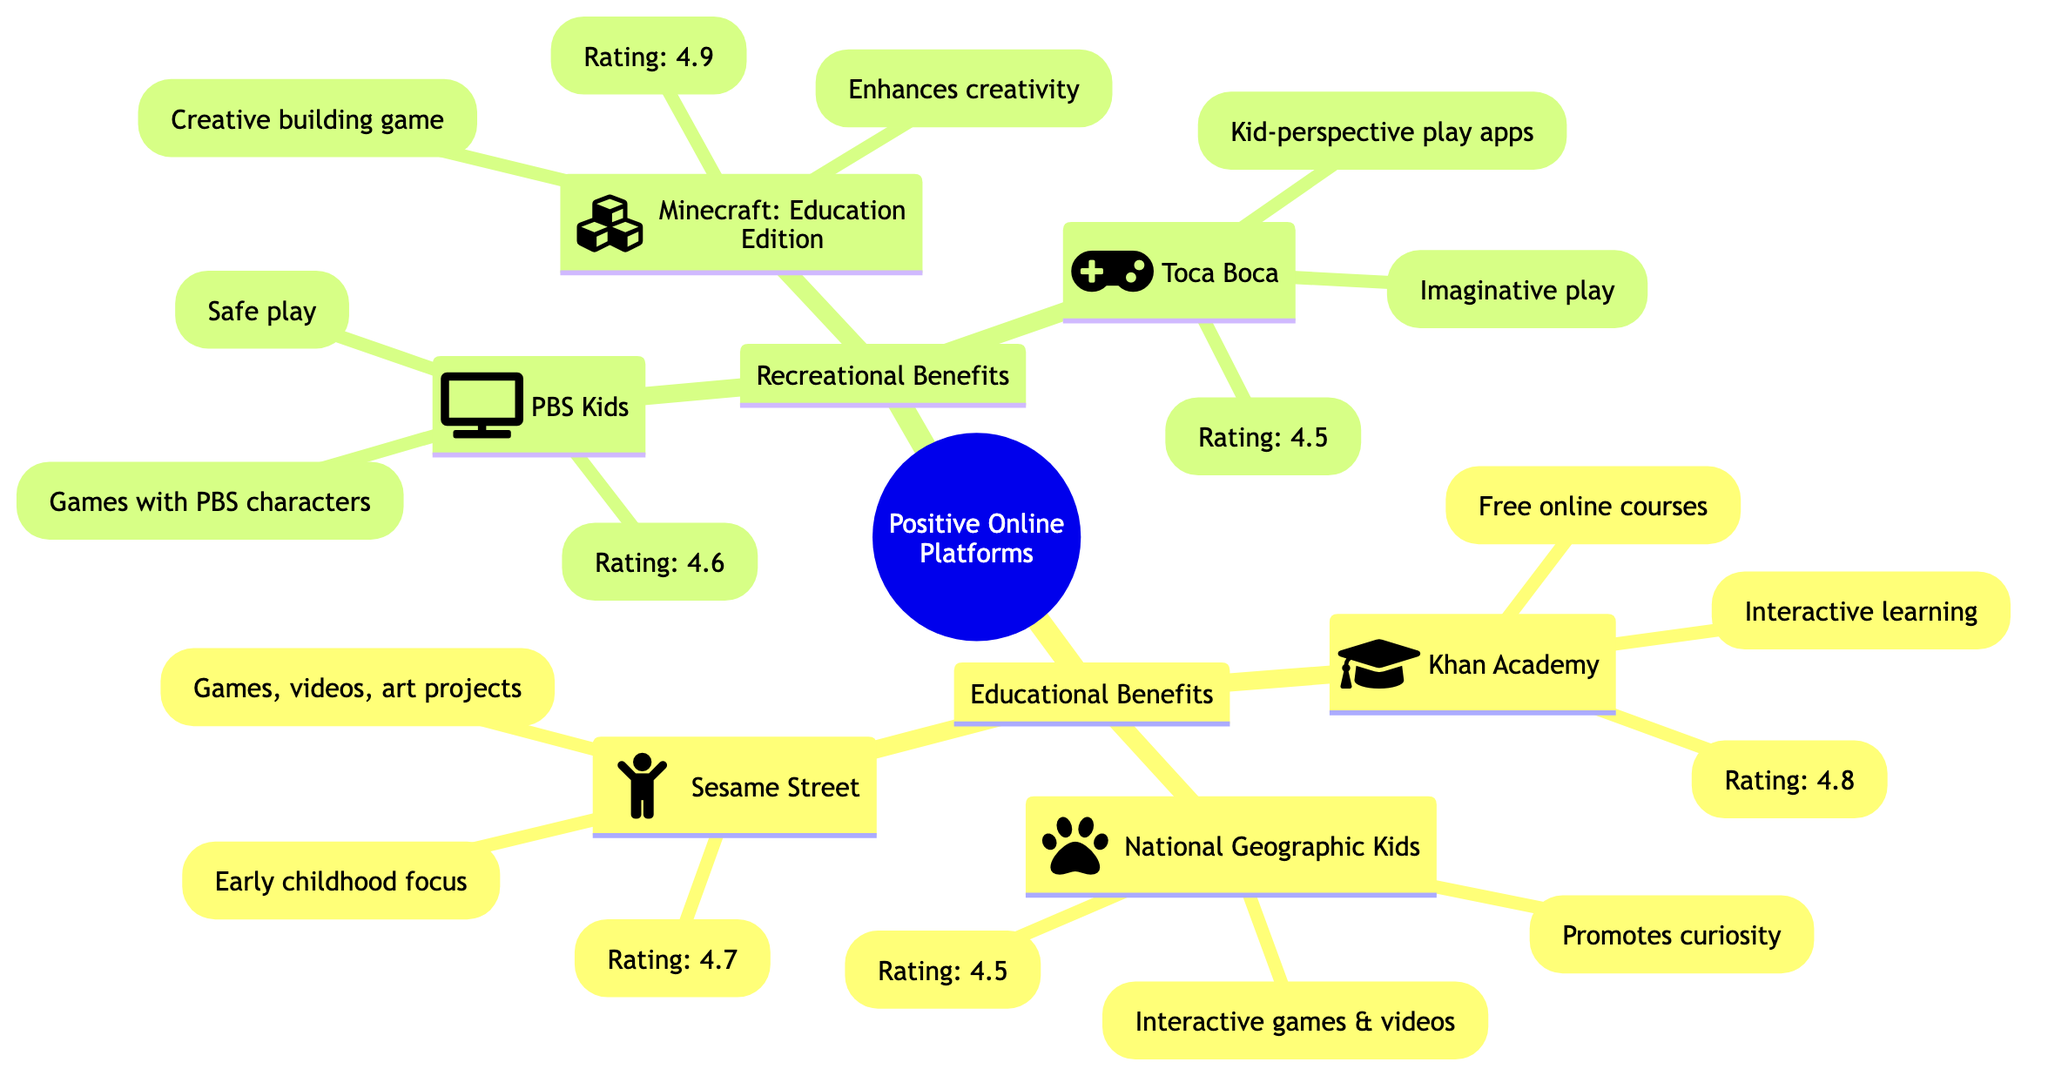What is the total number of platforms listed in the diagram? The diagram lists six distinct platforms contributing to the categories of educational and recreational benefits. Counting the nodes under each main category confirms the total of six.
Answer: 6 Which platform has the highest rating? By reviewing the ratings given in the diagram, Minecraft: Education Edition is identified with the highest rating of 4.9 among all listed platforms.
Answer: 4.9 What educational platform focuses on early childhood? In the educational benefits section, Sesame Street is specifically tailored towards early childhood learning as indicated by its description and icon.
Answer: Sesame Street Which platform offers creative building experiences? The description attached to Minecraft: Education Edition explicitly mentions "Creative building game," highlighting its focus on building creativity.
Answer: Minecraft: Education Edition How many platforms are categorized under Recreational Benefits? The diagram specifies three platforms listed under Recreational Benefits: PBS Kids, Minecraft: Education Edition, and Toca Boca. Counting these provides the answer.
Answer: 3 Which platform in the educational benefits section promotes curiosity? The description attached to National Geographic Kids states "Promotes curiosity," clearly identifying its purpose in that specific context.
Answer: National Geographic Kids What kind of activities does PBS Kids provide? The diagram states that PBS Kids focuses on "Games with PBS characters," reflecting the nature of activities available on that platform.
Answer: Games with PBS characters Which platform is associated with imaginative play? Upon analyzing the descriptions in the Recreational Benefits category, Toca Boca is noted for "Imaginative play," signifying its emphasis on that type of engagement for children.
Answer: Toca Boca How many platforms have a rating of 4.5 or higher? By evaluating the ratings for each platform, it is found that all six platforms (Khan Academy, National Geographic Kids, Sesame Street, PBS Kids, Minecraft: Education Edition, and Toca Boca) have ratings of 4.5 or above.
Answer: 6 